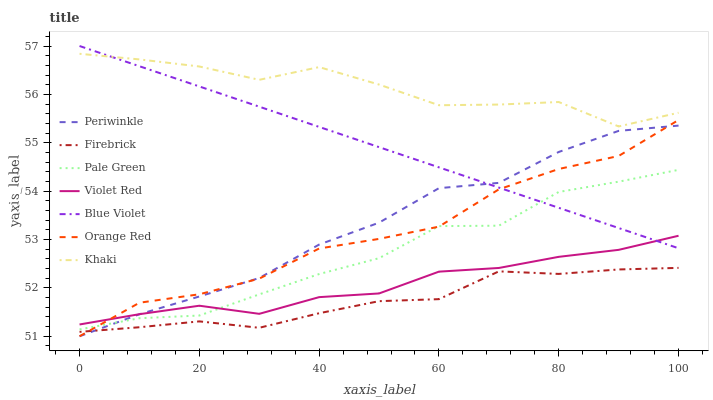Does Firebrick have the minimum area under the curve?
Answer yes or no. Yes. Does Khaki have the maximum area under the curve?
Answer yes or no. Yes. Does Khaki have the minimum area under the curve?
Answer yes or no. No. Does Firebrick have the maximum area under the curve?
Answer yes or no. No. Is Blue Violet the smoothest?
Answer yes or no. Yes. Is Khaki the roughest?
Answer yes or no. Yes. Is Firebrick the smoothest?
Answer yes or no. No. Is Firebrick the roughest?
Answer yes or no. No. Does Periwinkle have the lowest value?
Answer yes or no. Yes. Does Firebrick have the lowest value?
Answer yes or no. No. Does Blue Violet have the highest value?
Answer yes or no. Yes. Does Khaki have the highest value?
Answer yes or no. No. Is Violet Red less than Khaki?
Answer yes or no. Yes. Is Khaki greater than Firebrick?
Answer yes or no. Yes. Does Pale Green intersect Violet Red?
Answer yes or no. Yes. Is Pale Green less than Violet Red?
Answer yes or no. No. Is Pale Green greater than Violet Red?
Answer yes or no. No. Does Violet Red intersect Khaki?
Answer yes or no. No. 